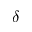Convert formula to latex. <formula><loc_0><loc_0><loc_500><loc_500>\delta</formula> 